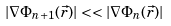Convert formula to latex. <formula><loc_0><loc_0><loc_500><loc_500>| \nabla \Phi _ { n + 1 } ( \vec { r } ) | < < | \nabla \Phi _ { n } ( \vec { r } ) |</formula> 